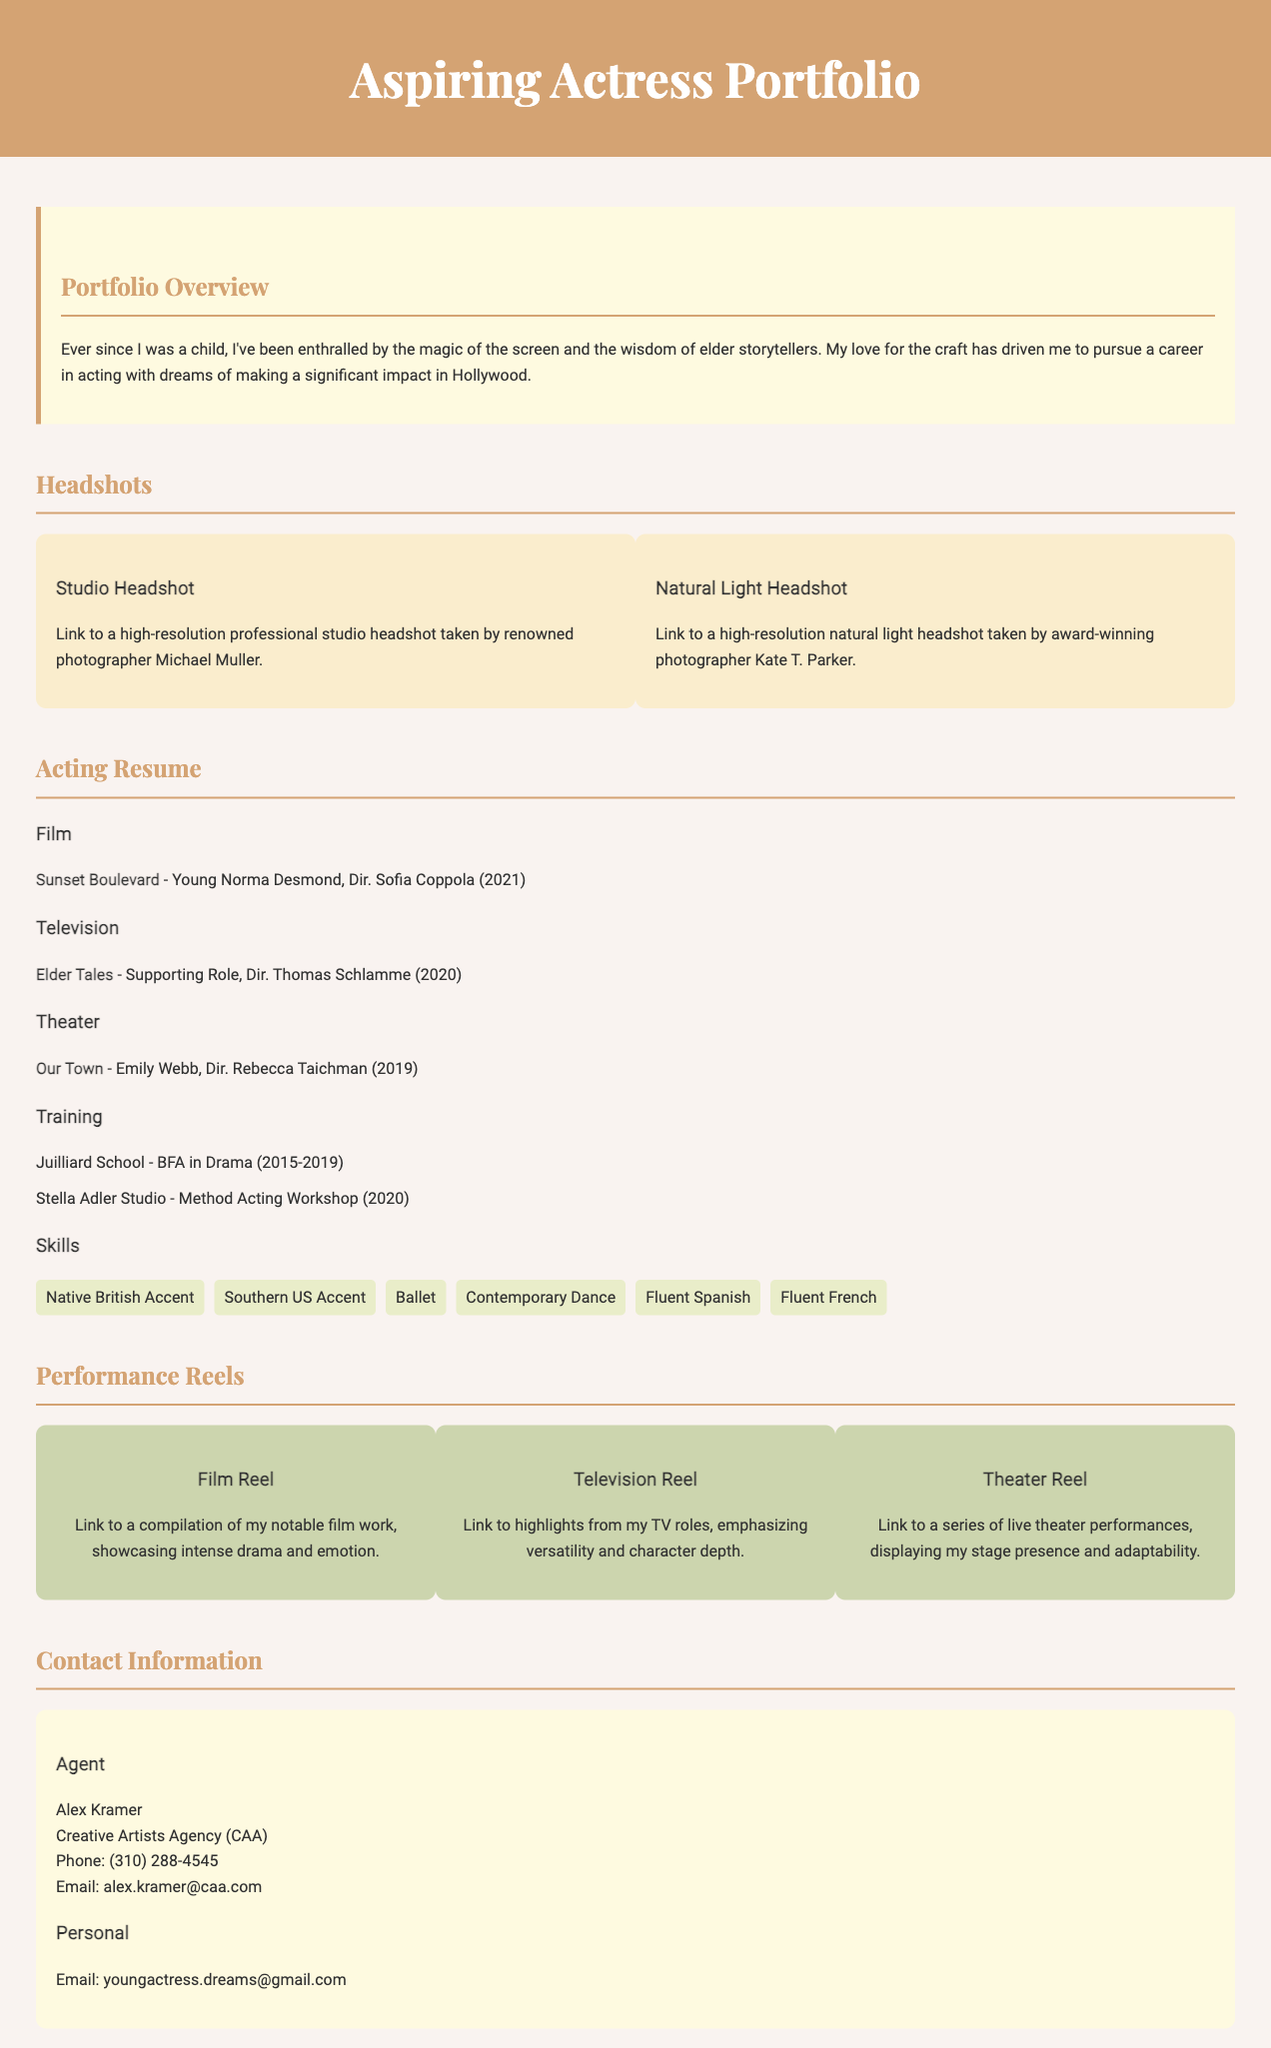What is the title of the portfolio? The title of the portfolio appears at the top of the document and is stated as "Aspiring Actress Portfolio."
Answer: Aspiring Actress Portfolio Who directed "Sunset Boulevard"? The document provides casting information, including the name of the director for "Sunset Boulevard," which is Sofia Coppola.
Answer: Sofia Coppola What was the supporting role in the television section? The television section lists the role played in the show "Elder Tales," which is a supporting role.
Answer: Supporting Role Which school did the actress train at for her BFA? The document specifies the institution where the actress completed her BFA in Drama, which is Juilliard School.
Answer: Juilliard School How many headshots are included in the portfolio? The portfolio contains descriptions of two headshots, namely a Studio Headshot and a Natural Light Headshot.
Answer: Two What language skills does the actress have? The skills list in the document mentions language skills, which include Fluent Spanish and Fluent French.
Answer: Fluent Spanish, Fluent French What is the name of the agent? The contact section of the document includes information about the agent being Alex Kramer.
Answer: Alex Kramer What type of reel showcases notable film work? The document indicates that the Film Reel showcases the actress's notable film work, emphasizing intense drama and emotion.
Answer: Film Reel 